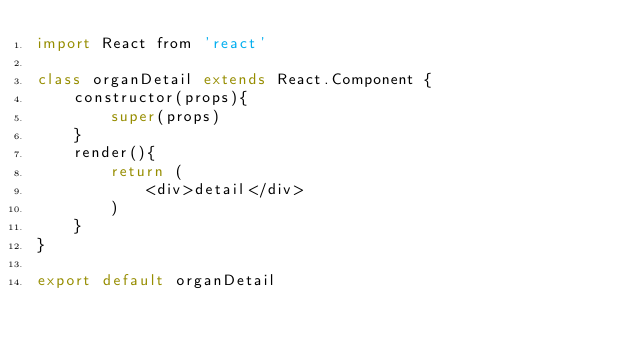Convert code to text. <code><loc_0><loc_0><loc_500><loc_500><_JavaScript_>import React from 'react'

class organDetail extends React.Component {
    constructor(props){
        super(props)
    }
    render(){
        return (
            <div>detail</div>
        )
    }
}

export default organDetail</code> 